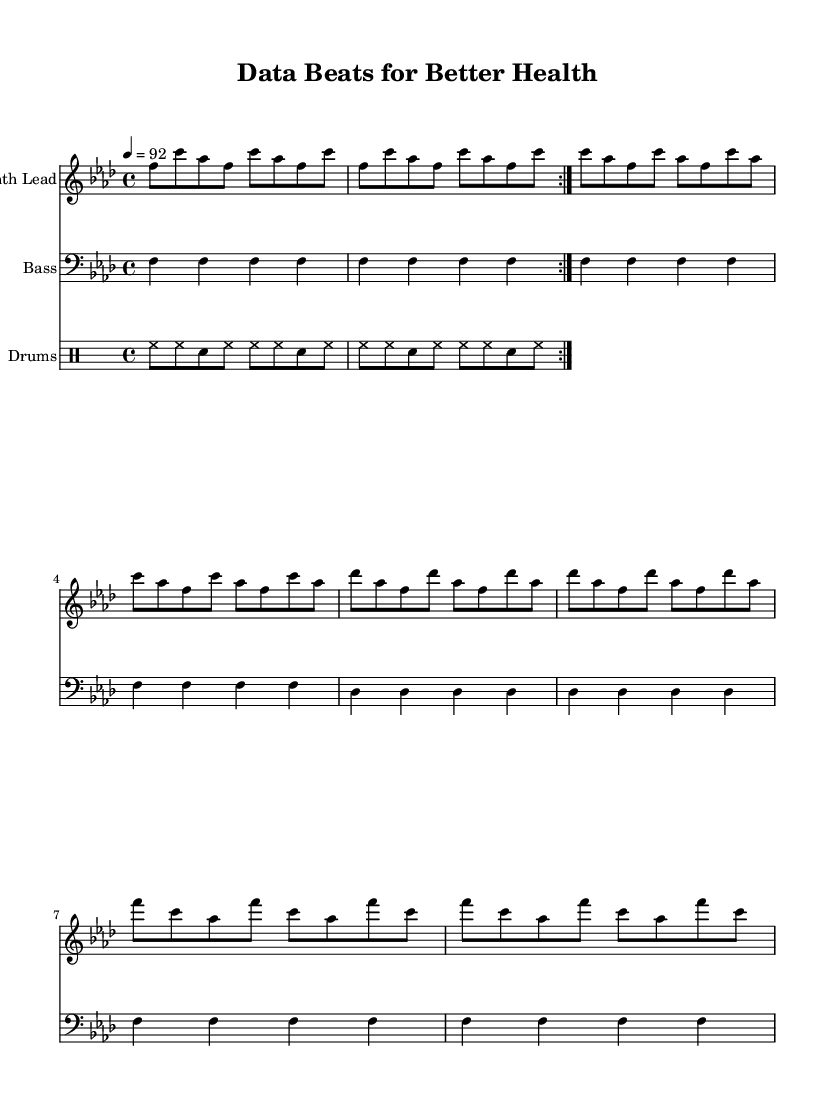What is the key signature of this music? The key signature is indicated by the flat signs on the staff. In this case, there are four flats, which corresponds to the key signature of F minor.
Answer: F minor What is the time signature of this music? The time signature appears at the beginning of the score; it is written as 4/4, indicating four beats per measure.
Answer: 4/4 What is the tempo marking for this piece? The tempo marking, given in beats per minute, is indicated as 4 = 92, which tells us the speed of the music.
Answer: 92 How many measures are in the melody section? By analyzing the melody part, we count the repeated sections and the lengths of each measure. The melody has 16 measures total when repeats are counted.
Answer: 16 What is the primary instrument featured in the melody? The instrument's name is assigned at the start of the staff where the melody is written. It is labeled as "Synth Lead."
Answer: Synth Lead What type of drum pattern is used in this piece? The drum pattern is indicated in the drum staff section. It consists of alternating hi-hats and snare hits, typical of Hip Hop.
Answer: Hi-hat and snare pattern What is the function of the bass in this composition? The bass part provides harmonic foundation and rhythmic pulse for the track. By looking at the bass line, you can see it moves primarily on long notes, reinforcing the chord structure.
Answer: Harmonic foundation 